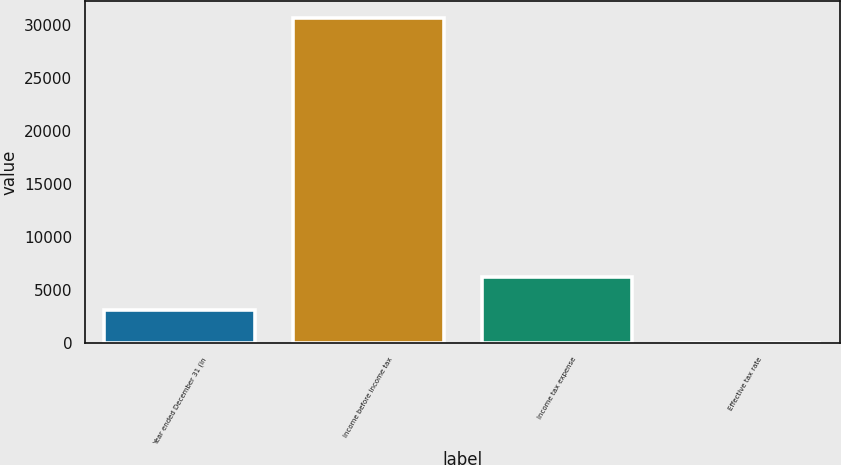Convert chart to OTSL. <chart><loc_0><loc_0><loc_500><loc_500><bar_chart><fcel>Year ended December 31 (in<fcel>Income before income tax<fcel>Income tax expense<fcel>Effective tax rate<nl><fcel>3088.56<fcel>30702<fcel>6260<fcel>20.4<nl></chart> 